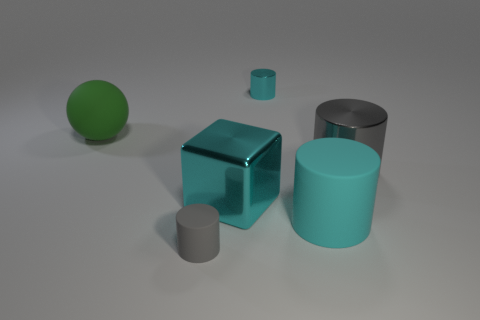Are there any other things that have the same color as the tiny metallic object?
Ensure brevity in your answer.  Yes. Is the color of the small shiny cylinder the same as the big sphere?
Ensure brevity in your answer.  No. What number of green things are large metal blocks or large balls?
Give a very brief answer. 1. Are there fewer big gray metal things that are in front of the big green object than small yellow cubes?
Ensure brevity in your answer.  No. There is a big cyan object behind the large cyan matte cylinder; what number of large metal cylinders are on the left side of it?
Keep it short and to the point. 0. How many other objects are the same size as the gray shiny thing?
Your response must be concise. 3. How many objects are either large balls or rubber objects that are in front of the large metal cylinder?
Your response must be concise. 3. Is the number of big cylinders less than the number of large cyan shiny cubes?
Offer a very short reply. No. There is a small object in front of the small thing behind the gray shiny cylinder; what is its color?
Offer a terse response. Gray. There is another large gray thing that is the same shape as the gray rubber thing; what is it made of?
Ensure brevity in your answer.  Metal. 